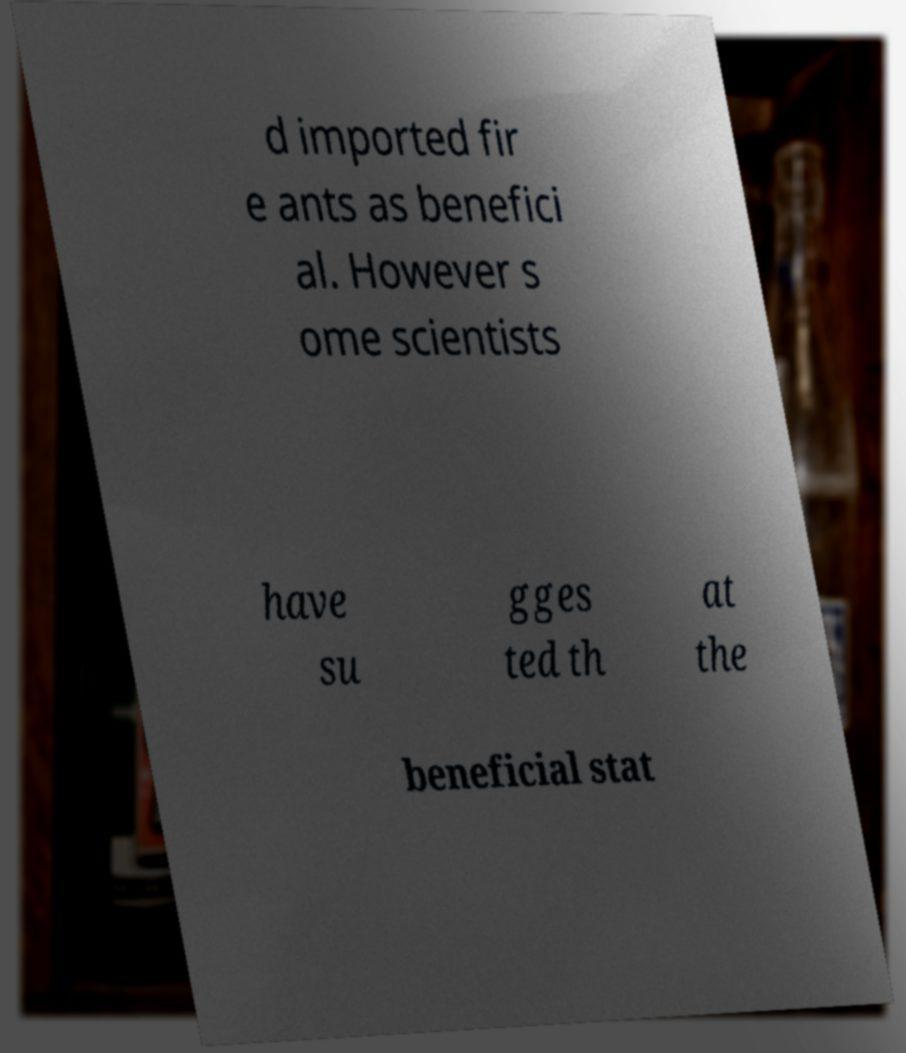Please read and relay the text visible in this image. What does it say? d imported fir e ants as benefici al. However s ome scientists have su gges ted th at the beneficial stat 